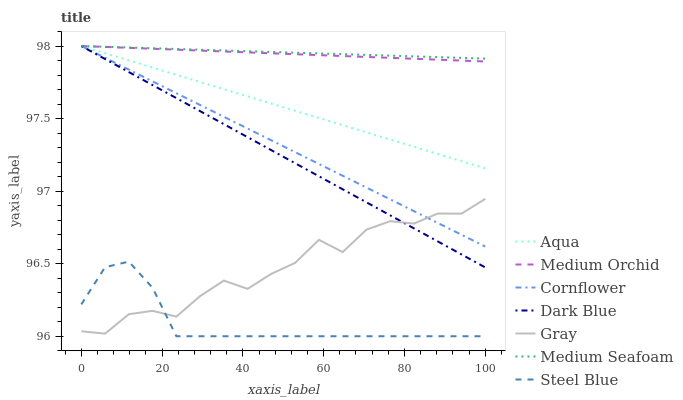Does Steel Blue have the minimum area under the curve?
Answer yes or no. Yes. Does Medium Seafoam have the maximum area under the curve?
Answer yes or no. Yes. Does Gray have the minimum area under the curve?
Answer yes or no. No. Does Gray have the maximum area under the curve?
Answer yes or no. No. Is Medium Seafoam the smoothest?
Answer yes or no. Yes. Is Gray the roughest?
Answer yes or no. Yes. Is Medium Orchid the smoothest?
Answer yes or no. No. Is Medium Orchid the roughest?
Answer yes or no. No. Does Steel Blue have the lowest value?
Answer yes or no. Yes. Does Gray have the lowest value?
Answer yes or no. No. Does Medium Seafoam have the highest value?
Answer yes or no. Yes. Does Gray have the highest value?
Answer yes or no. No. Is Steel Blue less than Aqua?
Answer yes or no. Yes. Is Aqua greater than Gray?
Answer yes or no. Yes. Does Gray intersect Steel Blue?
Answer yes or no. Yes. Is Gray less than Steel Blue?
Answer yes or no. No. Is Gray greater than Steel Blue?
Answer yes or no. No. Does Steel Blue intersect Aqua?
Answer yes or no. No. 